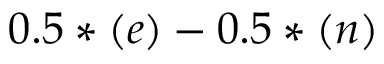<formula> <loc_0><loc_0><loc_500><loc_500>0 . 5 * ( e ) - 0 . 5 * ( n )</formula> 